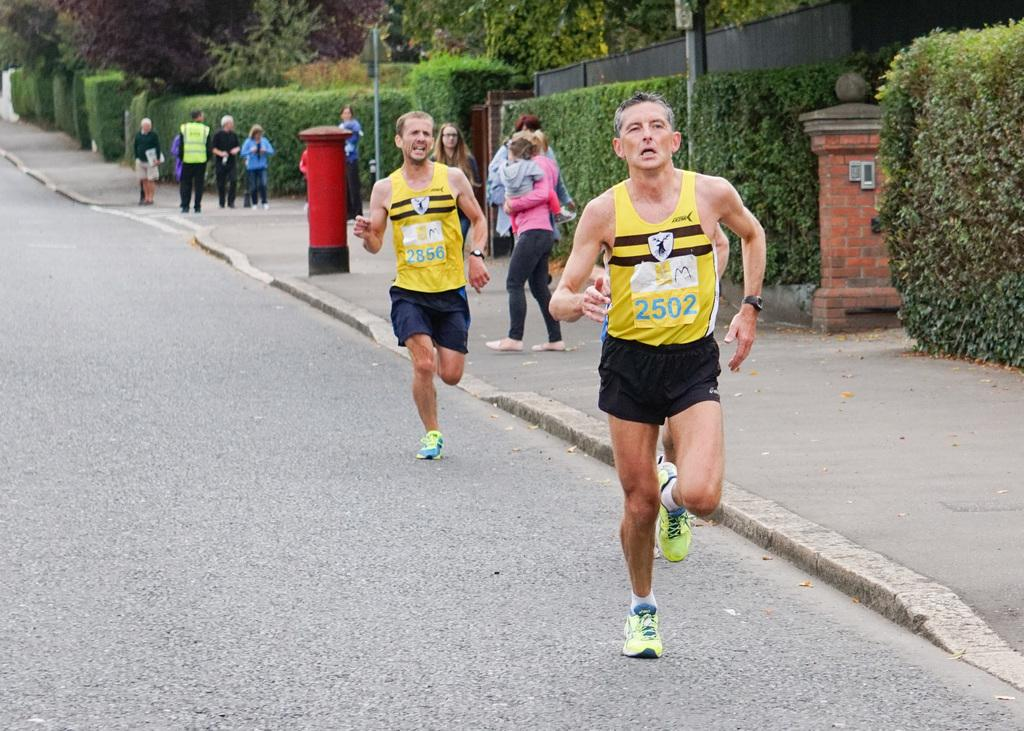What are the two people in the image doing? The two people in the image are running on the road. What can be seen in the background of the image? In the background, there is a group of people, poles, plants, trees, a wall, a post box, and other objects. Can you describe the group of people in the background? The group of people in the background is not clearly visible, but they are present. What type of bottle can be seen in the image? There is no bottle present in the image. 